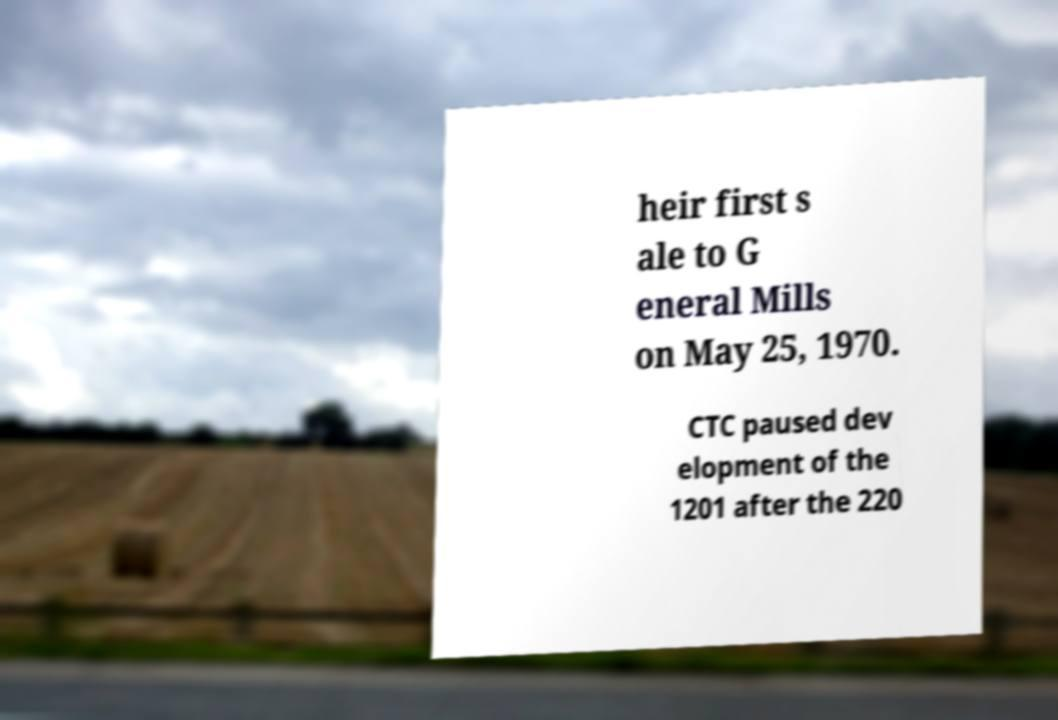What messages or text are displayed in this image? I need them in a readable, typed format. heir first s ale to G eneral Mills on May 25, 1970. CTC paused dev elopment of the 1201 after the 220 